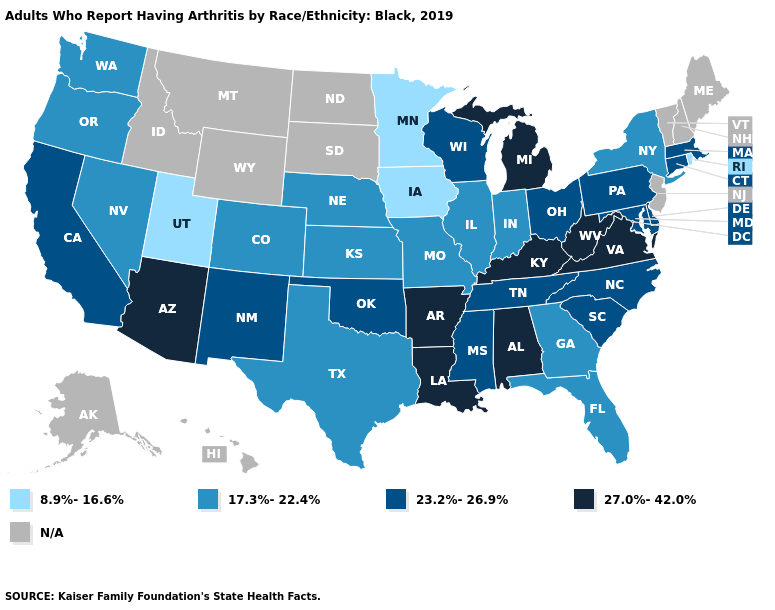What is the value of Wisconsin?
Quick response, please. 23.2%-26.9%. Does the map have missing data?
Quick response, please. Yes. Does Arizona have the highest value in the USA?
Keep it brief. Yes. Which states have the highest value in the USA?
Quick response, please. Alabama, Arizona, Arkansas, Kentucky, Louisiana, Michigan, Virginia, West Virginia. Is the legend a continuous bar?
Be succinct. No. Name the states that have a value in the range 8.9%-16.6%?
Concise answer only. Iowa, Minnesota, Rhode Island, Utah. Which states have the lowest value in the USA?
Be succinct. Iowa, Minnesota, Rhode Island, Utah. Which states hav the highest value in the MidWest?
Write a very short answer. Michigan. Among the states that border North Dakota , which have the lowest value?
Concise answer only. Minnesota. What is the lowest value in states that border Illinois?
Be succinct. 8.9%-16.6%. What is the value of Maine?
Be succinct. N/A. What is the lowest value in the USA?
Keep it brief. 8.9%-16.6%. Which states hav the highest value in the West?
Short answer required. Arizona. What is the lowest value in states that border Florida?
Give a very brief answer. 17.3%-22.4%. 